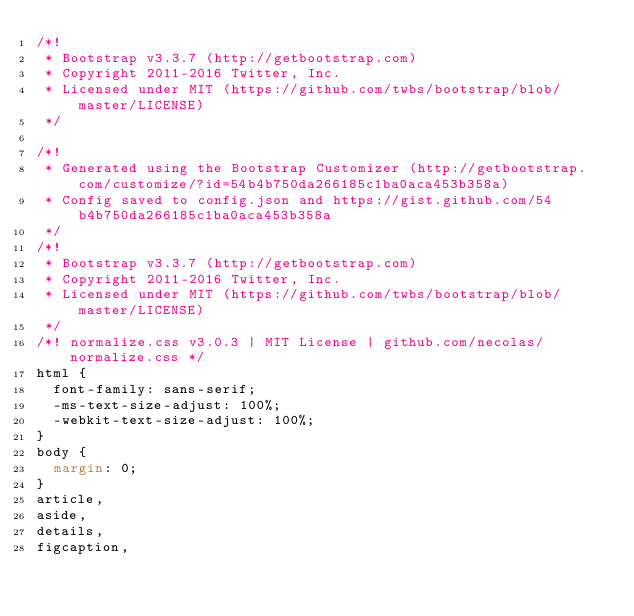<code> <loc_0><loc_0><loc_500><loc_500><_CSS_>/*!
 * Bootstrap v3.3.7 (http://getbootstrap.com)
 * Copyright 2011-2016 Twitter, Inc.
 * Licensed under MIT (https://github.com/twbs/bootstrap/blob/master/LICENSE)
 */

/*!
 * Generated using the Bootstrap Customizer (http://getbootstrap.com/customize/?id=54b4b750da266185c1ba0aca453b358a)
 * Config saved to config.json and https://gist.github.com/54b4b750da266185c1ba0aca453b358a
 */
/*!
 * Bootstrap v3.3.7 (http://getbootstrap.com)
 * Copyright 2011-2016 Twitter, Inc.
 * Licensed under MIT (https://github.com/twbs/bootstrap/blob/master/LICENSE)
 */
/*! normalize.css v3.0.3 | MIT License | github.com/necolas/normalize.css */
html {
  font-family: sans-serif;
  -ms-text-size-adjust: 100%;
  -webkit-text-size-adjust: 100%;
}
body {
  margin: 0;
}
article,
aside,
details,
figcaption,</code> 